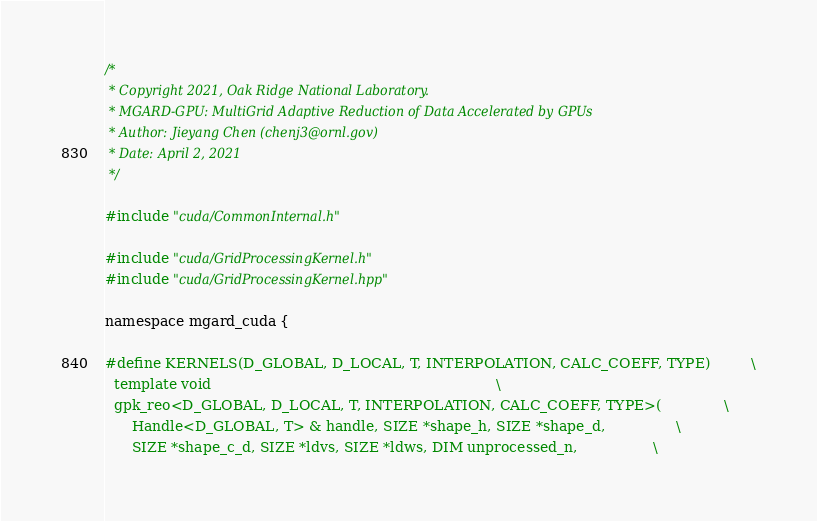Convert code to text. <code><loc_0><loc_0><loc_500><loc_500><_Cuda_>/*
 * Copyright 2021, Oak Ridge National Laboratory.
 * MGARD-GPU: MultiGrid Adaptive Reduction of Data Accelerated by GPUs
 * Author: Jieyang Chen (chenj3@ornl.gov)
 * Date: April 2, 2021
 */

#include "cuda/CommonInternal.h"
 
#include "cuda/GridProcessingKernel.h"
#include "cuda/GridProcessingKernel.hpp"

namespace mgard_cuda {

#define KERNELS(D_GLOBAL, D_LOCAL, T, INTERPOLATION, CALC_COEFF, TYPE)         \
  template void                                                                \
  gpk_reo<D_GLOBAL, D_LOCAL, T, INTERPOLATION, CALC_COEFF, TYPE>(              \
      Handle<D_GLOBAL, T> & handle, SIZE *shape_h, SIZE *shape_d,                \
      SIZE *shape_c_d, SIZE *ldvs, SIZE *ldws, DIM unprocessed_n,                 \</code> 